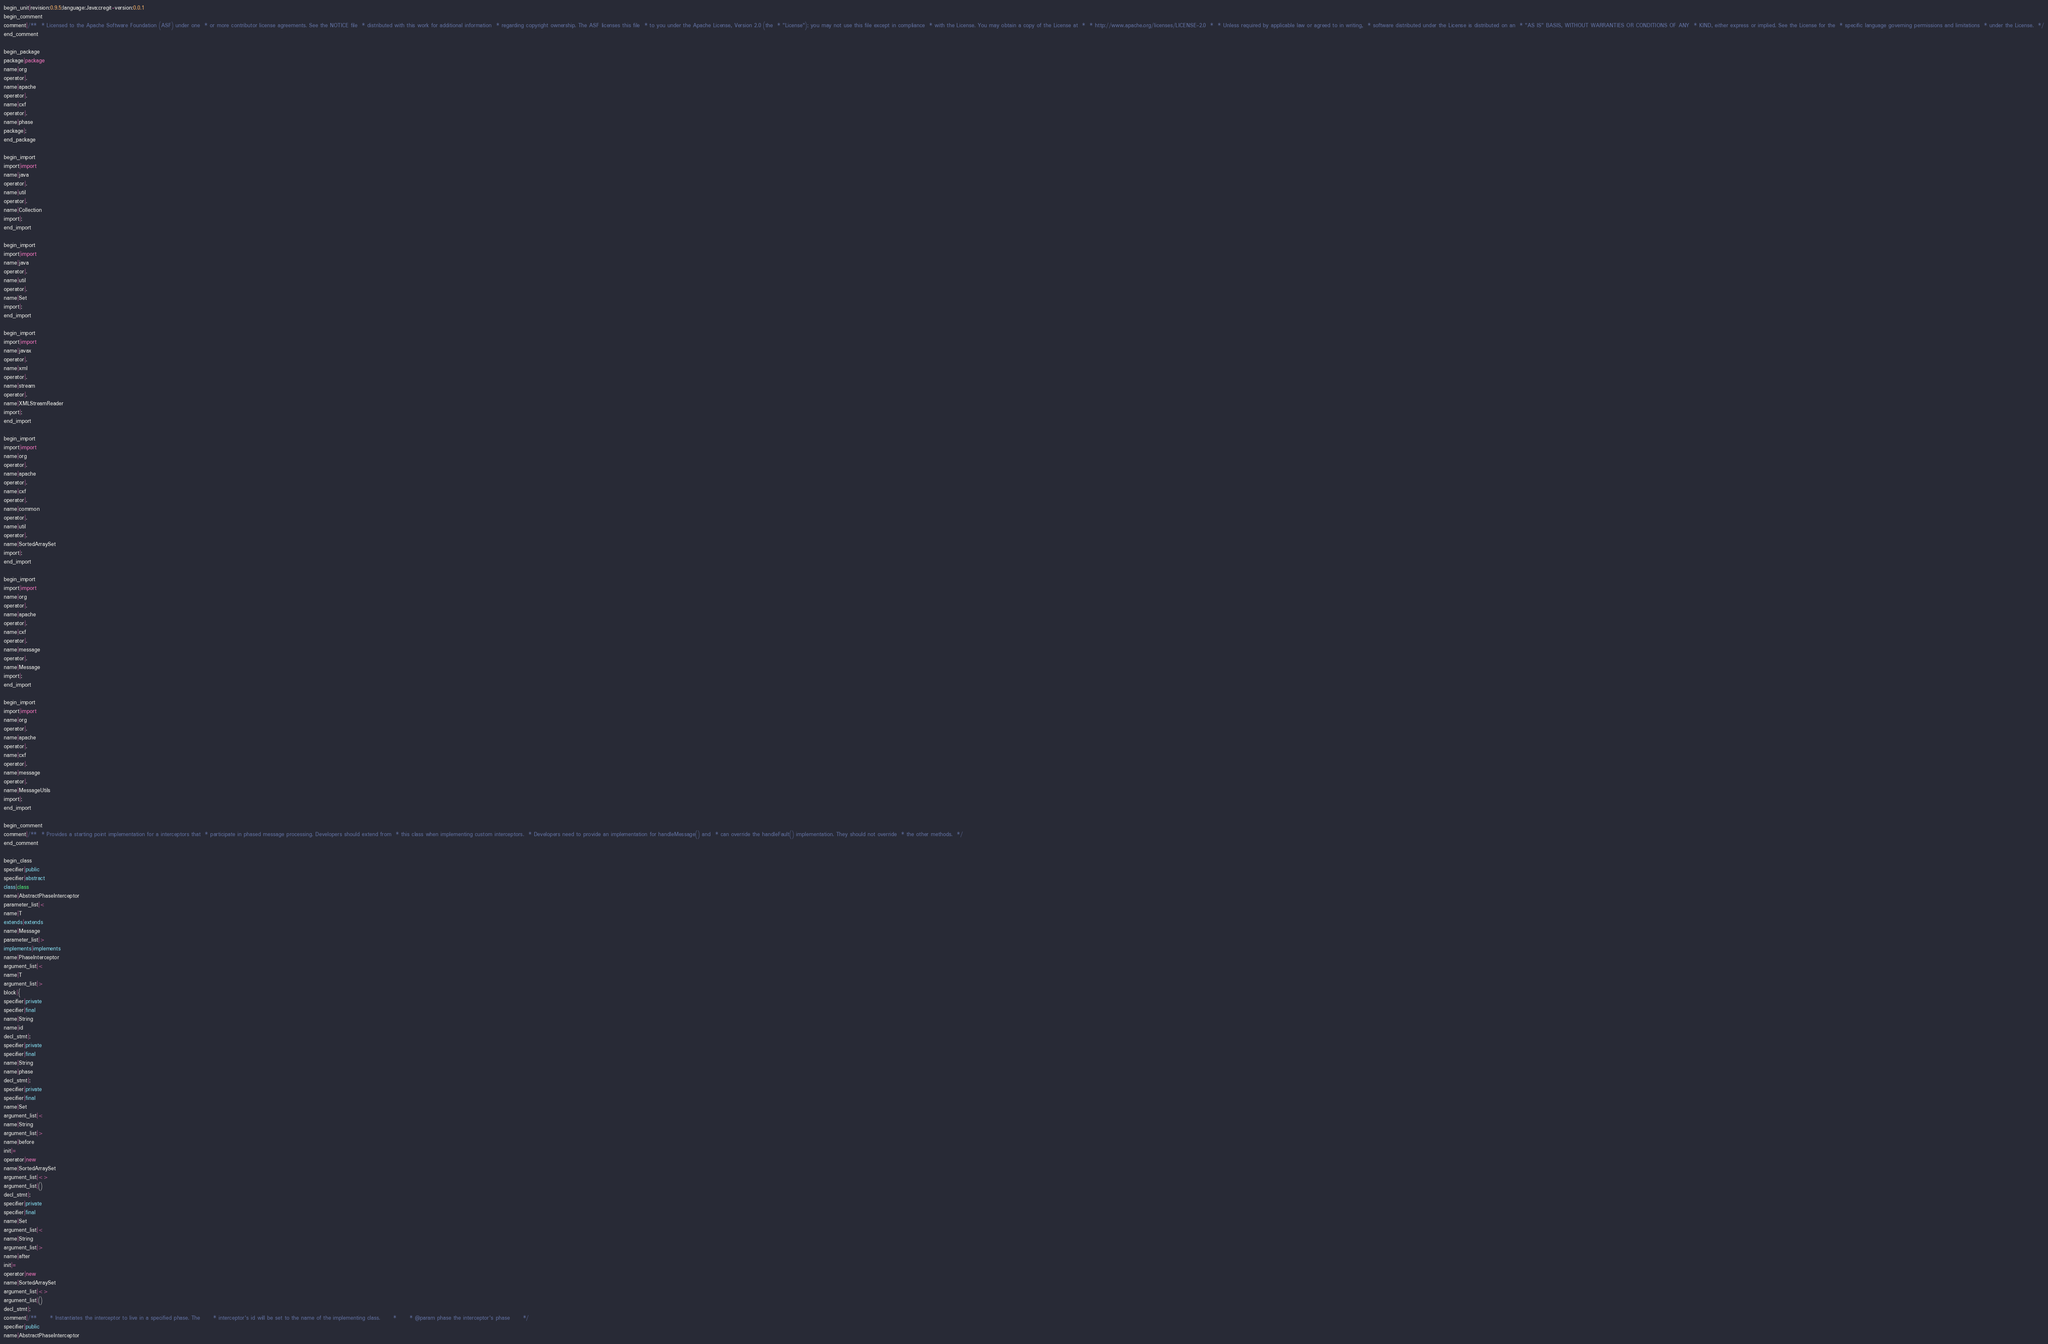<code> <loc_0><loc_0><loc_500><loc_500><_Java_>begin_unit|revision:0.9.5;language:Java;cregit-version:0.0.1
begin_comment
comment|/**  * Licensed to the Apache Software Foundation (ASF) under one  * or more contributor license agreements. See the NOTICE file  * distributed with this work for additional information  * regarding copyright ownership. The ASF licenses this file  * to you under the Apache License, Version 2.0 (the  * "License"); you may not use this file except in compliance  * with the License. You may obtain a copy of the License at  *  * http://www.apache.org/licenses/LICENSE-2.0  *  * Unless required by applicable law or agreed to in writing,  * software distributed under the License is distributed on an  * "AS IS" BASIS, WITHOUT WARRANTIES OR CONDITIONS OF ANY  * KIND, either express or implied. See the License for the  * specific language governing permissions and limitations  * under the License.  */
end_comment

begin_package
package|package
name|org
operator|.
name|apache
operator|.
name|cxf
operator|.
name|phase
package|;
end_package

begin_import
import|import
name|java
operator|.
name|util
operator|.
name|Collection
import|;
end_import

begin_import
import|import
name|java
operator|.
name|util
operator|.
name|Set
import|;
end_import

begin_import
import|import
name|javax
operator|.
name|xml
operator|.
name|stream
operator|.
name|XMLStreamReader
import|;
end_import

begin_import
import|import
name|org
operator|.
name|apache
operator|.
name|cxf
operator|.
name|common
operator|.
name|util
operator|.
name|SortedArraySet
import|;
end_import

begin_import
import|import
name|org
operator|.
name|apache
operator|.
name|cxf
operator|.
name|message
operator|.
name|Message
import|;
end_import

begin_import
import|import
name|org
operator|.
name|apache
operator|.
name|cxf
operator|.
name|message
operator|.
name|MessageUtils
import|;
end_import

begin_comment
comment|/**  * Provides a starting point implementation for a interceptors that  * participate in phased message processing. Developers should extend from  * this class when implementing custom interceptors.  * Developers need to provide an implementation for handleMessage() and  * can override the handleFault() implementation. They should not override  * the other methods.  */
end_comment

begin_class
specifier|public
specifier|abstract
class|class
name|AbstractPhaseInterceptor
parameter_list|<
name|T
extends|extends
name|Message
parameter_list|>
implements|implements
name|PhaseInterceptor
argument_list|<
name|T
argument_list|>
block|{
specifier|private
specifier|final
name|String
name|id
decl_stmt|;
specifier|private
specifier|final
name|String
name|phase
decl_stmt|;
specifier|private
specifier|final
name|Set
argument_list|<
name|String
argument_list|>
name|before
init|=
operator|new
name|SortedArraySet
argument_list|<>
argument_list|()
decl_stmt|;
specifier|private
specifier|final
name|Set
argument_list|<
name|String
argument_list|>
name|after
init|=
operator|new
name|SortedArraySet
argument_list|<>
argument_list|()
decl_stmt|;
comment|/**      * Instantiates the interceptor to live in a specified phase. The      * interceptor's id will be set to the name of the implementing class.      *      * @param phase the interceptor's phase      */
specifier|public
name|AbstractPhaseInterceptor</code> 